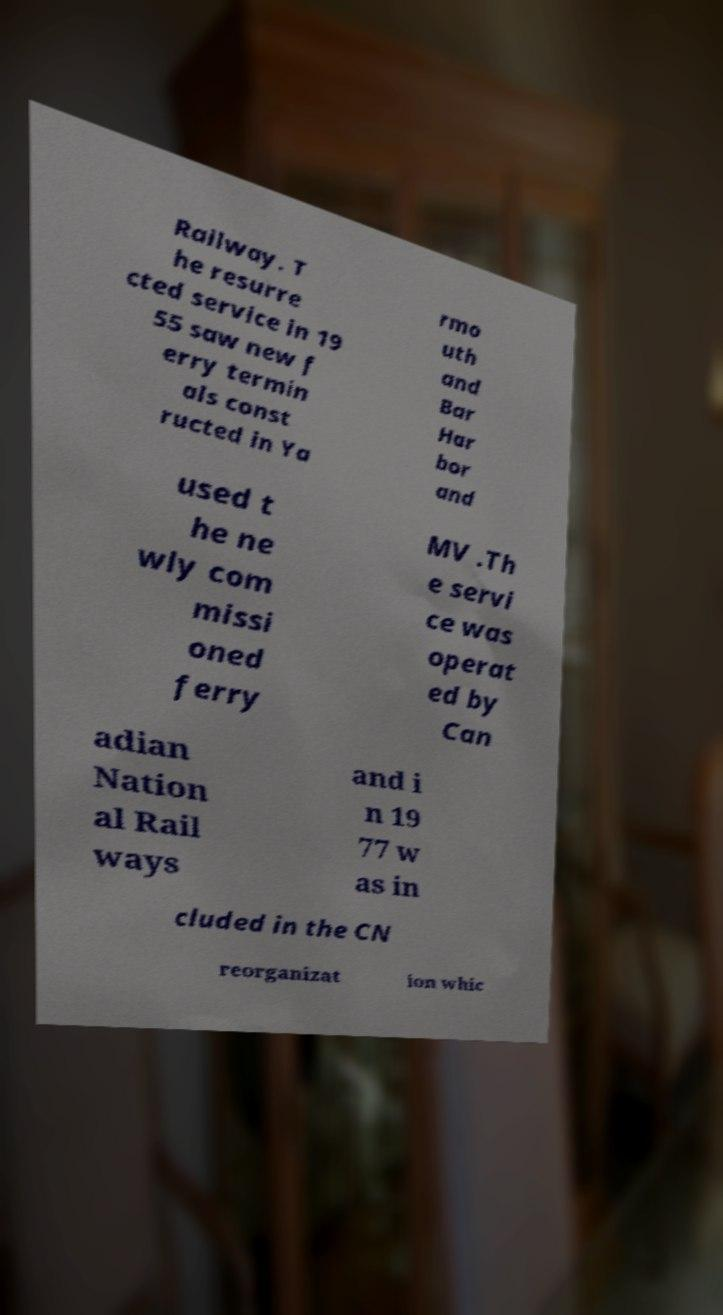Can you read and provide the text displayed in the image?This photo seems to have some interesting text. Can you extract and type it out for me? Railway. T he resurre cted service in 19 55 saw new f erry termin als const ructed in Ya rmo uth and Bar Har bor and used t he ne wly com missi oned ferry MV .Th e servi ce was operat ed by Can adian Nation al Rail ways and i n 19 77 w as in cluded in the CN reorganizat ion whic 